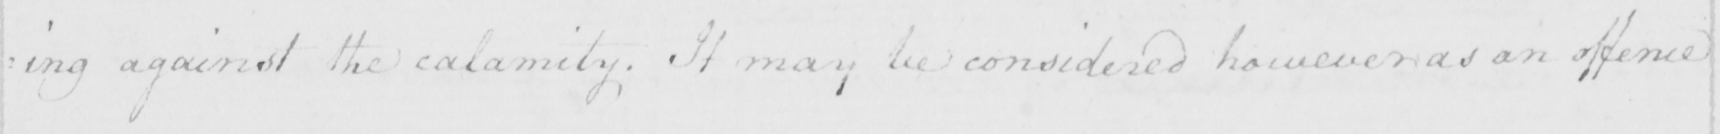Can you read and transcribe this handwriting? : ding against the calamity ; It may be considered however as an offence 